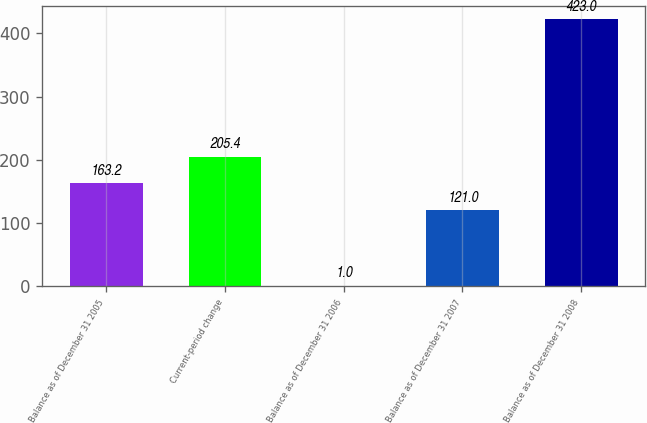Convert chart. <chart><loc_0><loc_0><loc_500><loc_500><bar_chart><fcel>Balance as of December 31 2005<fcel>Current-period change<fcel>Balance as of December 31 2006<fcel>Balance as of December 31 2007<fcel>Balance as of December 31 2008<nl><fcel>163.2<fcel>205.4<fcel>1<fcel>121<fcel>423<nl></chart> 